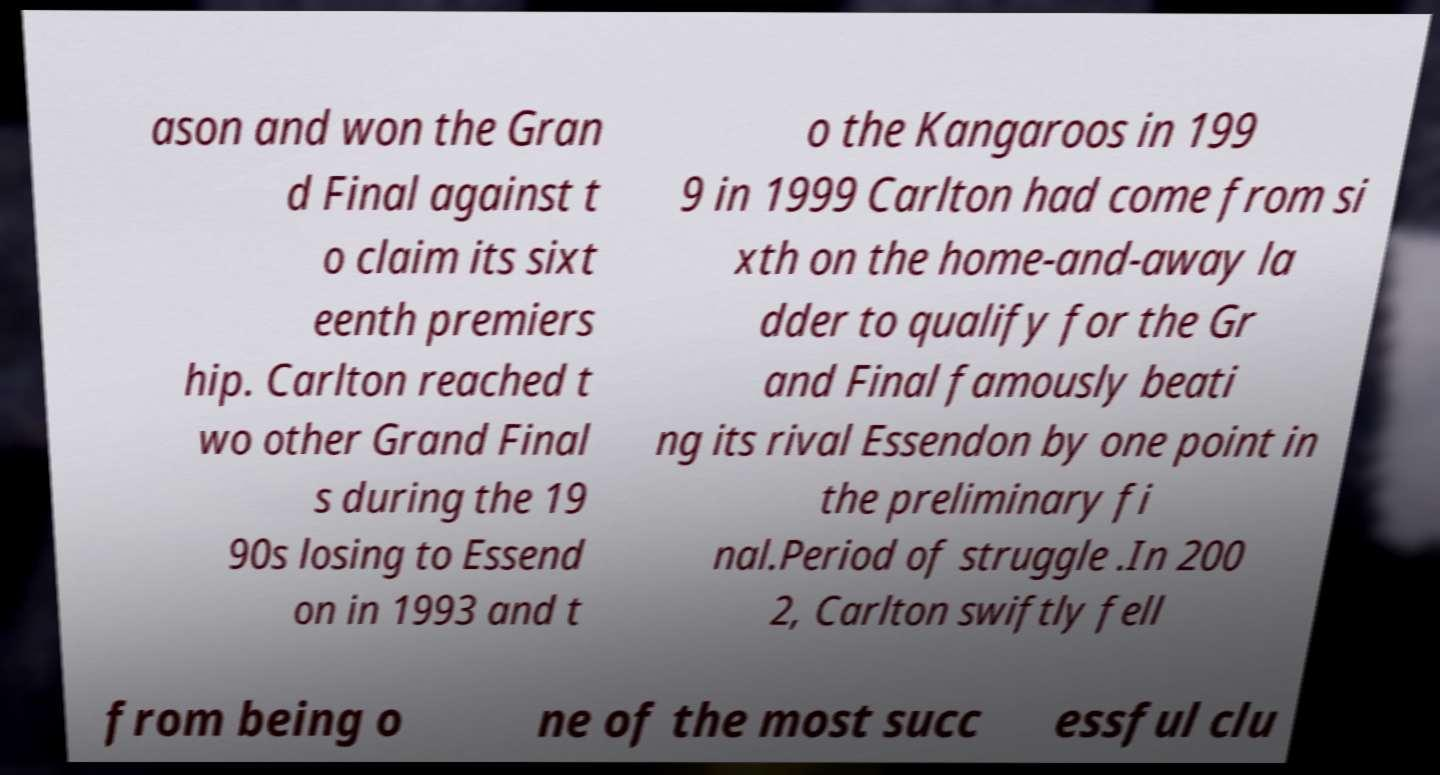What messages or text are displayed in this image? I need them in a readable, typed format. ason and won the Gran d Final against t o claim its sixt eenth premiers hip. Carlton reached t wo other Grand Final s during the 19 90s losing to Essend on in 1993 and t o the Kangaroos in 199 9 in 1999 Carlton had come from si xth on the home-and-away la dder to qualify for the Gr and Final famously beati ng its rival Essendon by one point in the preliminary fi nal.Period of struggle .In 200 2, Carlton swiftly fell from being o ne of the most succ essful clu 